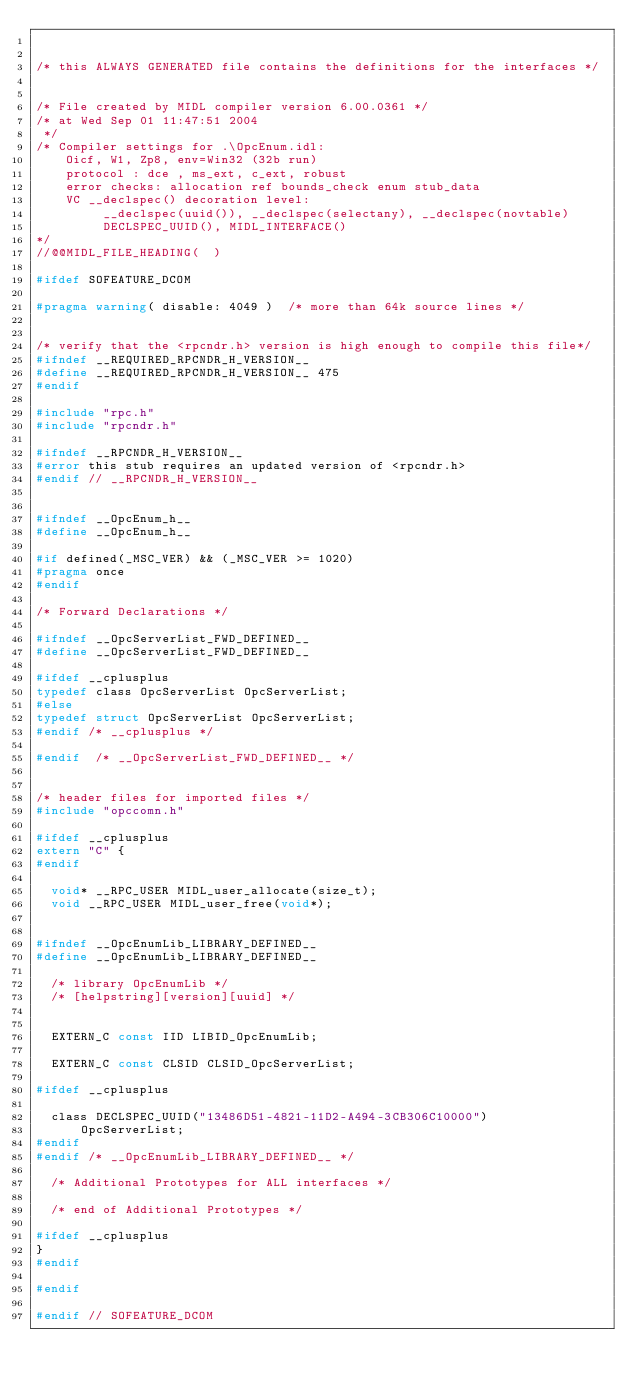Convert code to text. <code><loc_0><loc_0><loc_500><loc_500><_C_>

/* this ALWAYS GENERATED file contains the definitions for the interfaces */


/* File created by MIDL compiler version 6.00.0361 */
/* at Wed Sep 01 11:47:51 2004
 */
/* Compiler settings for .\OpcEnum.idl:
    Oicf, W1, Zp8, env=Win32 (32b run)
    protocol : dce , ms_ext, c_ext, robust
    error checks: allocation ref bounds_check enum stub_data
    VC __declspec() decoration level:
         __declspec(uuid()), __declspec(selectany), __declspec(novtable)
         DECLSPEC_UUID(), MIDL_INTERFACE()
*/
//@@MIDL_FILE_HEADING(  )

#ifdef SOFEATURE_DCOM

#pragma warning( disable: 4049 )  /* more than 64k source lines */


/* verify that the <rpcndr.h> version is high enough to compile this file*/
#ifndef __REQUIRED_RPCNDR_H_VERSION__
#define __REQUIRED_RPCNDR_H_VERSION__ 475
#endif

#include "rpc.h"
#include "rpcndr.h"

#ifndef __RPCNDR_H_VERSION__
#error this stub requires an updated version of <rpcndr.h>
#endif // __RPCNDR_H_VERSION__


#ifndef __OpcEnum_h__
#define __OpcEnum_h__

#if defined(_MSC_VER) && (_MSC_VER >= 1020)
#pragma once
#endif

/* Forward Declarations */

#ifndef __OpcServerList_FWD_DEFINED__
#define __OpcServerList_FWD_DEFINED__

#ifdef __cplusplus
typedef class OpcServerList OpcServerList;
#else
typedef struct OpcServerList OpcServerList;
#endif /* __cplusplus */

#endif  /* __OpcServerList_FWD_DEFINED__ */


/* header files for imported files */
#include "opccomn.h"

#ifdef __cplusplus
extern "C" {
#endif

	void* __RPC_USER MIDL_user_allocate(size_t);
	void __RPC_USER MIDL_user_free(void*);


#ifndef __OpcEnumLib_LIBRARY_DEFINED__
#define __OpcEnumLib_LIBRARY_DEFINED__

	/* library OpcEnumLib */
	/* [helpstring][version][uuid] */


	EXTERN_C const IID LIBID_OpcEnumLib;

	EXTERN_C const CLSID CLSID_OpcServerList;

#ifdef __cplusplus

	class DECLSPEC_UUID("13486D51-4821-11D2-A494-3CB306C10000")
			OpcServerList;
#endif
#endif /* __OpcEnumLib_LIBRARY_DEFINED__ */

	/* Additional Prototypes for ALL interfaces */

	/* end of Additional Prototypes */

#ifdef __cplusplus
}
#endif

#endif

#endif // SOFEATURE_DCOM

</code> 